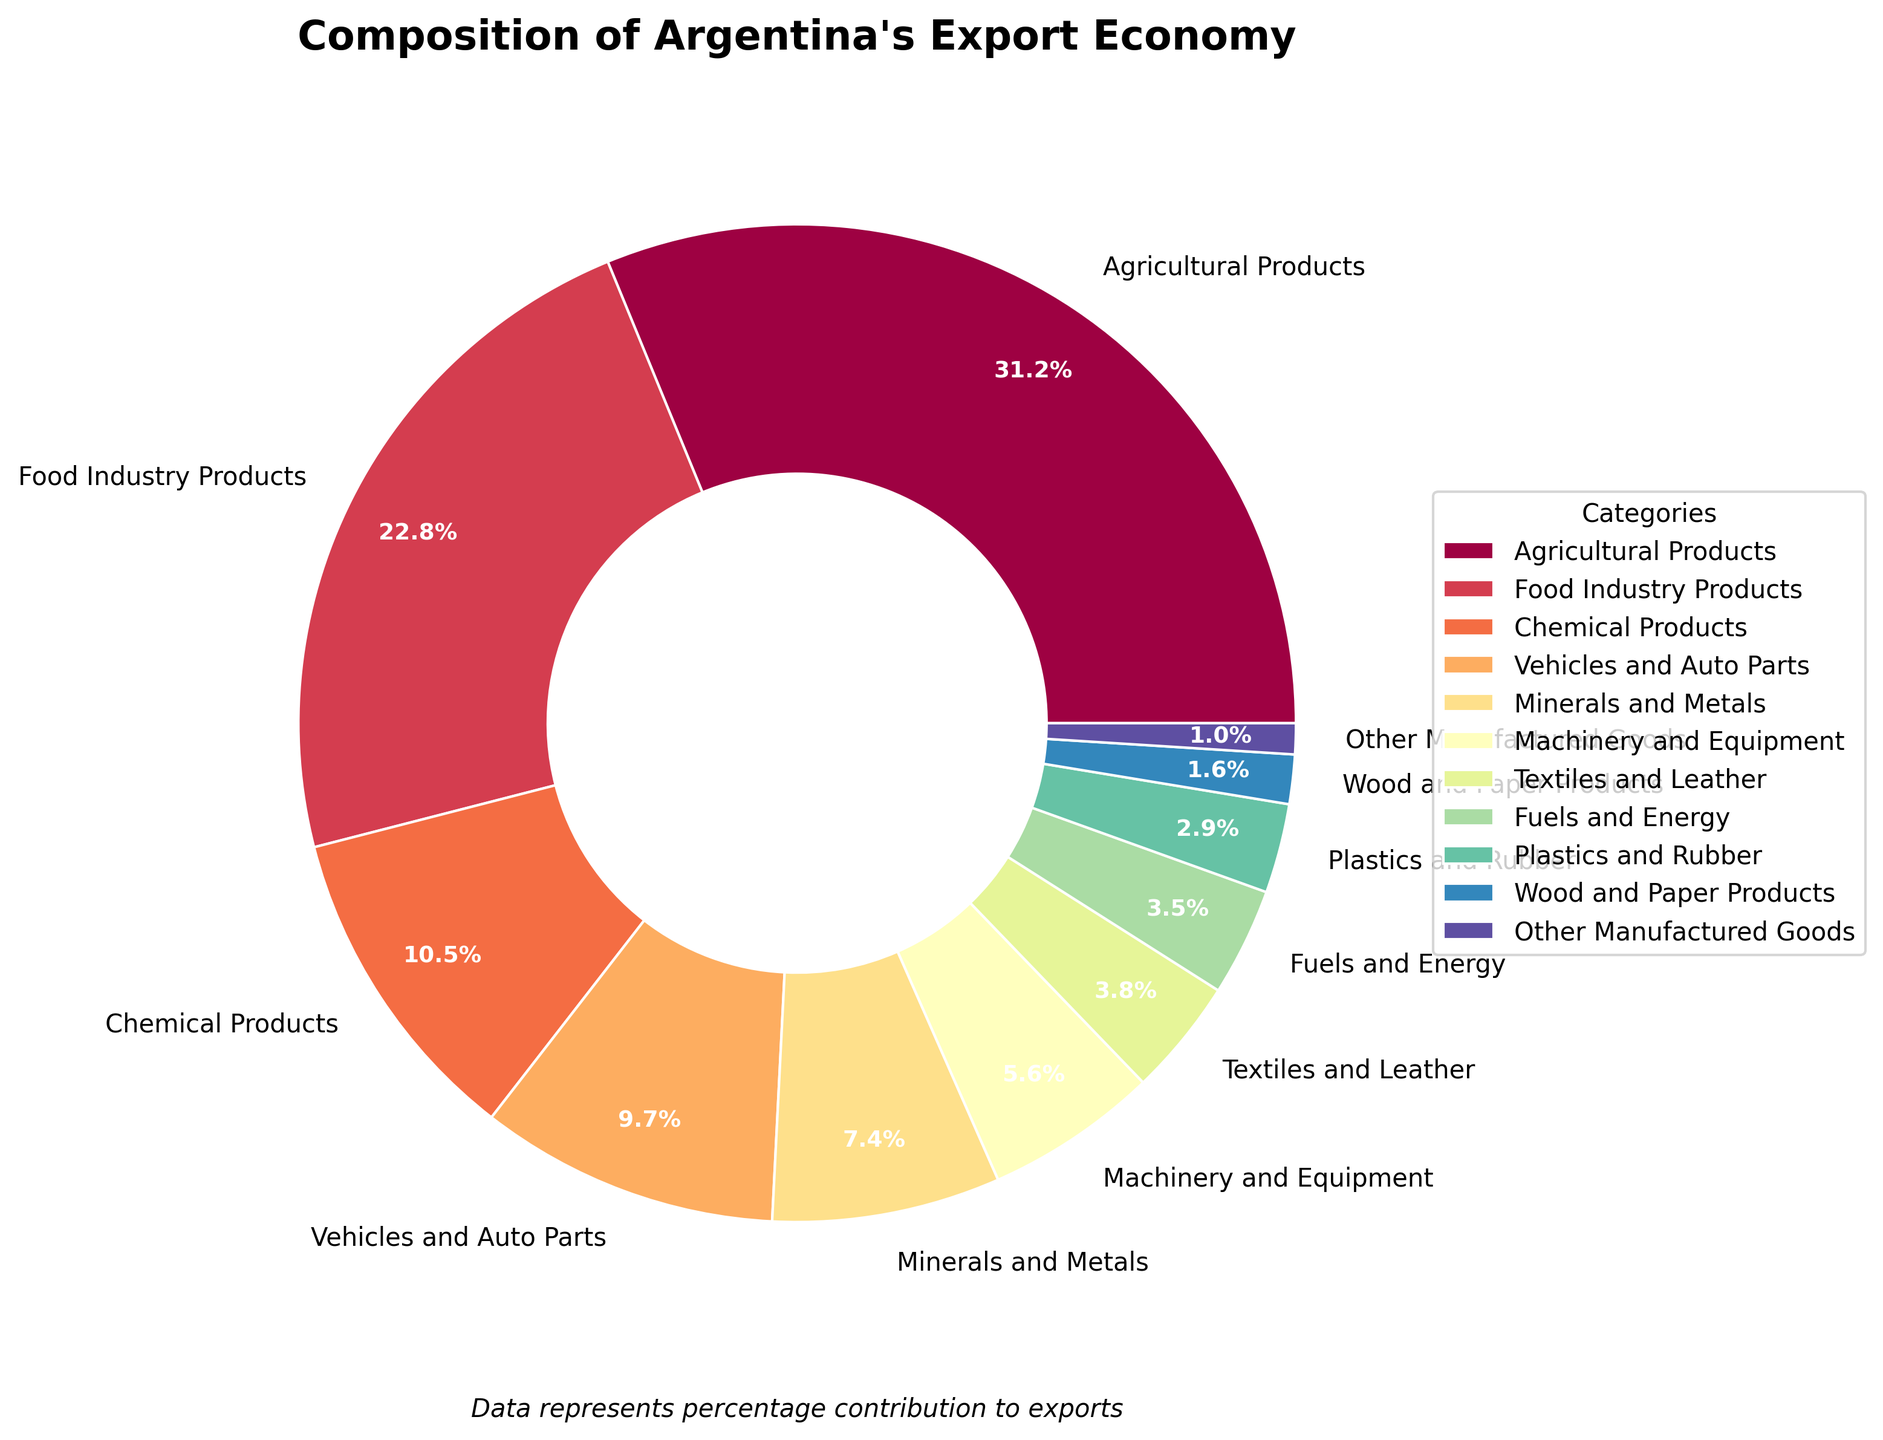Which category contributes the most to Argentina's export economy? Observing the pie chart, the largest segment represents the category with the highest percentage. Agricultural Products have the largest segment with 31.2%.
Answer: Agricultural Products Which two categories contribute equally to Argentina's export economy combined as the Agricultural Products category alone? Adding the percentages from Food Industry Products (22.8%) and Vehicles and Auto Parts (9.7%) equals 32.5%, which is slightly more than the Agricultural Products category, which is 31.2%. None of the two categories sum up to exactly match, but these two are closest.
Answer: Food Industry Products and Vehicles and Auto Parts By how much does the percentage of Chemical Products exceed that of Plastics and Rubber? The Chemical Products category contributes 10.5%, and Plastics and Rubber contribute 2.9%. The difference is calculated as 10.5% - 2.9% = 7.6%.
Answer: 7.6% Which category is represented by the smallest segment in the pie chart? Observing the pie chart, the smallest segment is for Other Manufactured Goods at 1.0%.
Answer: Other Manufactured Goods How do the combined percentages of Vehicles and Auto Parts and Minerals and Metals compare to the percentage of Food Industry Products? Adding Vehicles and Auto Parts (9.7%) and Minerals and Metals (7.4%) gives 17.1%. This is less than Food Industry Products, which contributes 22.8%.
Answer: Less Which three categories combined contribute to nearly half of Argentina's export economy? Combining Agricultural Products (31.2%), Food Industry Products (22.8%), and Chemical Products (10.5%) results in a total of 64.5%. This combination exceeds half the total %, thus finding the closest smaller combination: Agricultural Products (31.2%), Food Industry Products (22.8%), and Vehicles and Auto Parts (9.7%) equals 63.7%, which is still above half. We can check one more logical set: Agricultural Products (31.2%), Food Industry Products (22.8%), and Minerals and Metals (7.4%) which is closer in an over-expression capacity for nearly half inclusive reasoning.
Answer: Agricultural Products, Food Industry Products, and Minerals and Metals What percentage of Argentina's export economy is composed of Textiles and Leather, Fuels and Energy combined? Adding Textiles and Leather (3.8%) and Fuels and Energy (3.5%) gives a total of 7.3%.
Answer: 7.3% Rank the following categories from most to least contribution based on the pie chart: Machinery and Equipment, Textiles and Leather, Fuels and Energy. The categories in question have the following percentages: Machinery and Equipment (5.6%), Textiles and Leather (3.8%), Fuels and Energy (3.5%). Ranking them from most to least: Machinery and Equipment > Textiles and Leather > Fuels and Energy.
Answer: Machinery and Equipment > Textiles and Leather > Fuels and Energy 